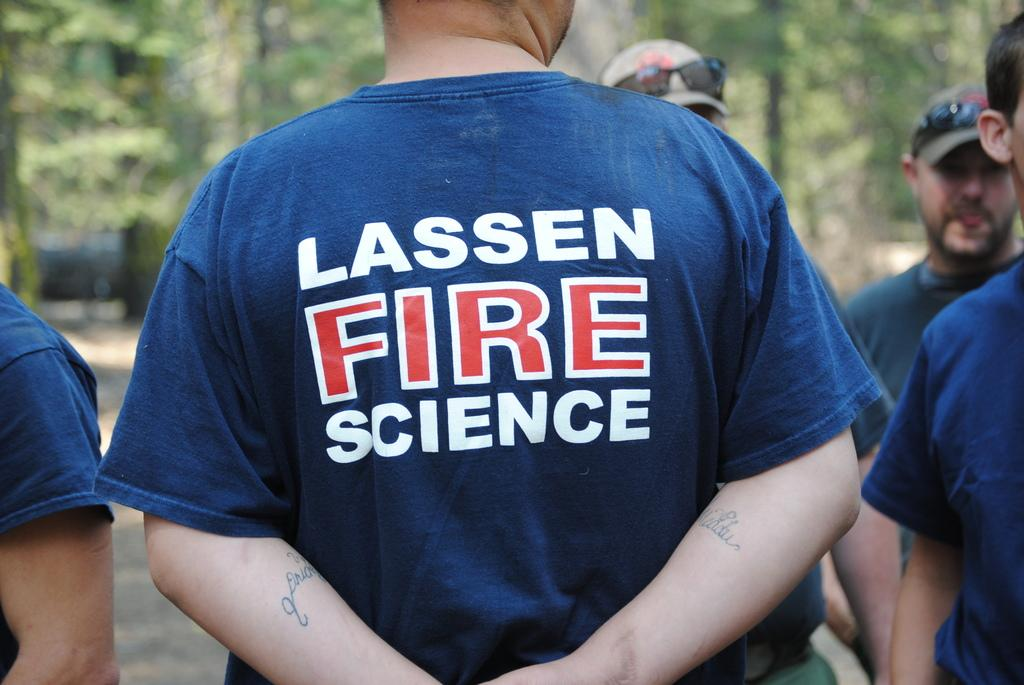<image>
Create a compact narrative representing the image presented. A man in a blue shirt that says Lassen Fire Science on the back. 